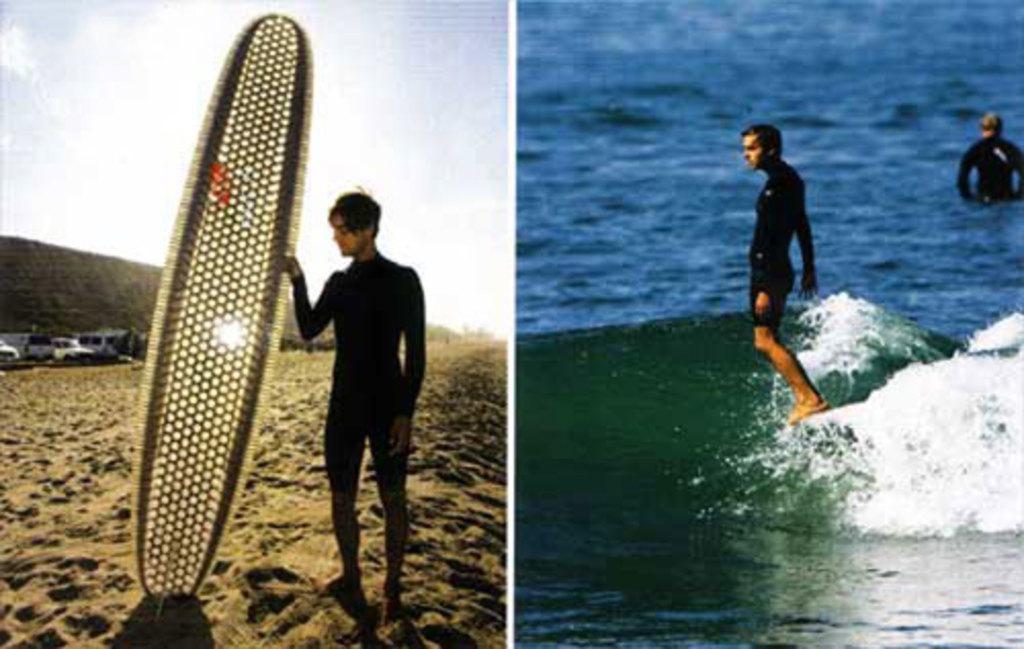Could you give a brief overview of what you see in this image? In this image I can see a person holding and another person is surfing. 